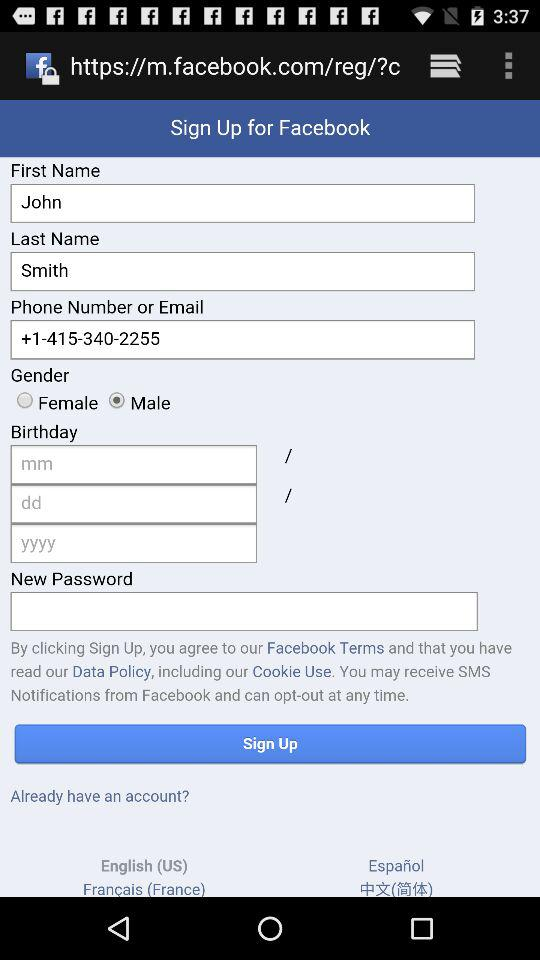What application is the signup for? The signup is for "Facebook". 